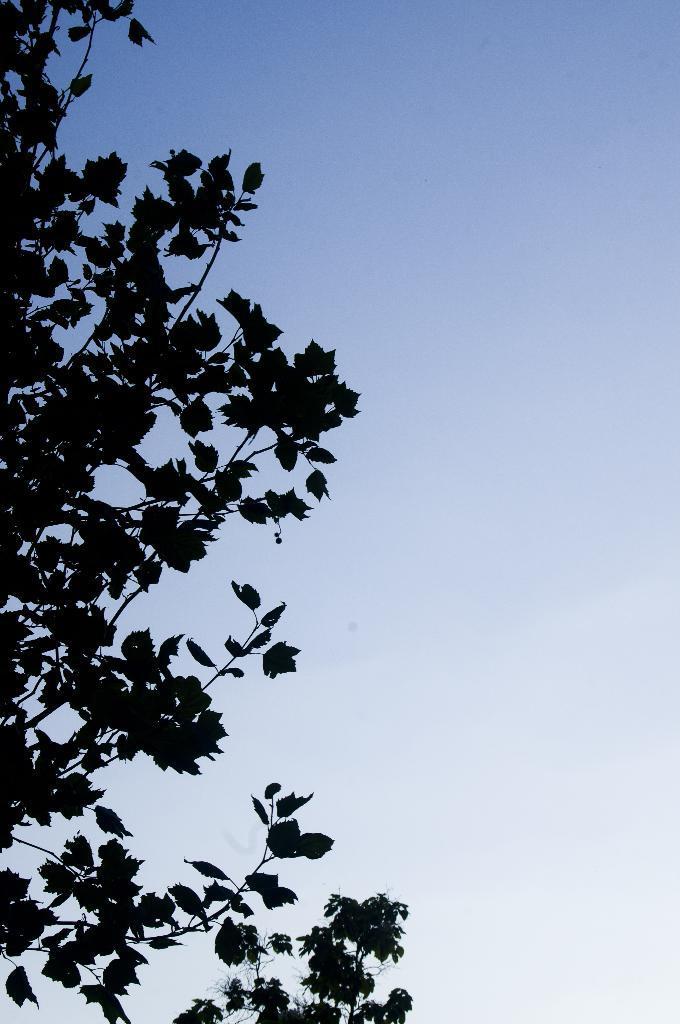How would you summarize this image in a sentence or two? In this image I can see the trees. In the background I can see the sky. 